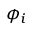<formula> <loc_0><loc_0><loc_500><loc_500>\phi _ { i }</formula> 